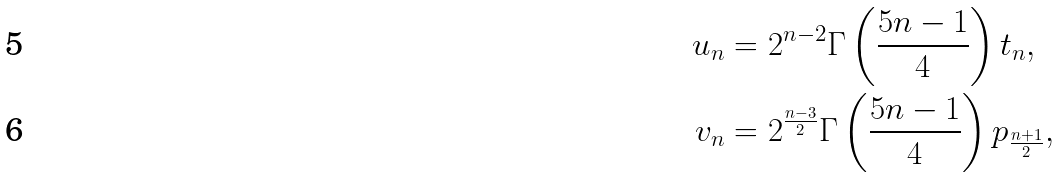Convert formula to latex. <formula><loc_0><loc_0><loc_500><loc_500>u _ { n } & = 2 ^ { n - 2 } \Gamma \left ( \frac { 5 n - 1 } { 4 } \right ) t _ { n } , \\ v _ { n } & = 2 ^ { \frac { n - 3 } { 2 } } \Gamma \left ( \frac { 5 n - 1 } { 4 } \right ) p _ { \frac { n + 1 } { 2 } } ,</formula> 